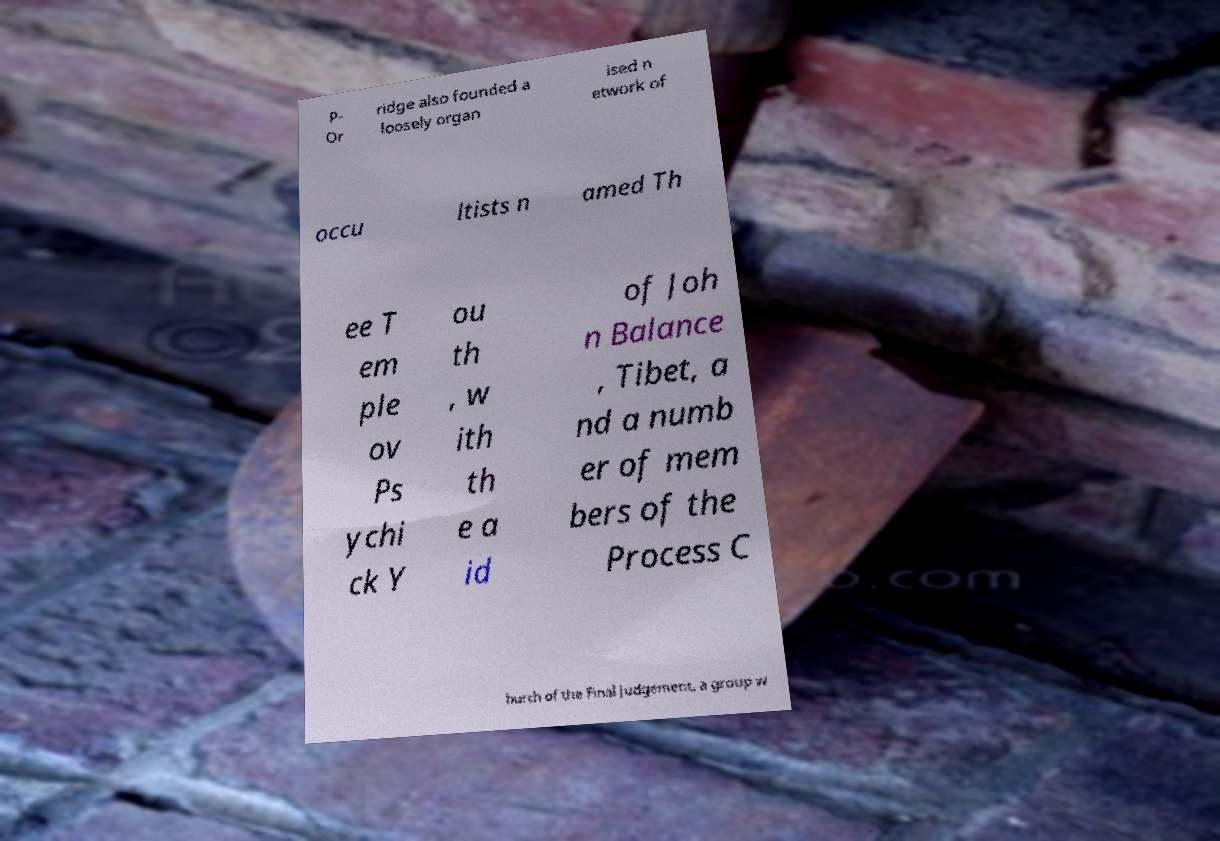Could you assist in decoding the text presented in this image and type it out clearly? P- Or ridge also founded a loosely organ ised n etwork of occu ltists n amed Th ee T em ple ov Ps ychi ck Y ou th , w ith th e a id of Joh n Balance , Tibet, a nd a numb er of mem bers of the Process C hurch of the Final Judgement, a group w 